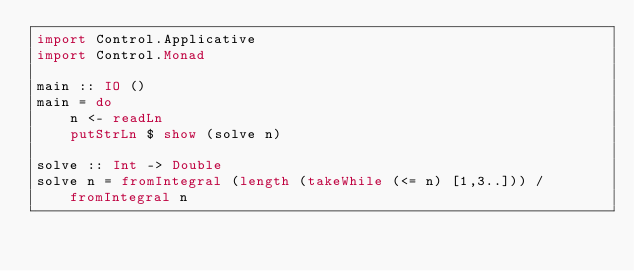Convert code to text. <code><loc_0><loc_0><loc_500><loc_500><_Haskell_>import Control.Applicative
import Control.Monad
 
main :: IO ()
main = do
    n <- readLn
    putStrLn $ show (solve n)
    
solve :: Int -> Double
solve n = fromIntegral (length (takeWhile (<= n) [1,3..])) / fromIntegral n</code> 